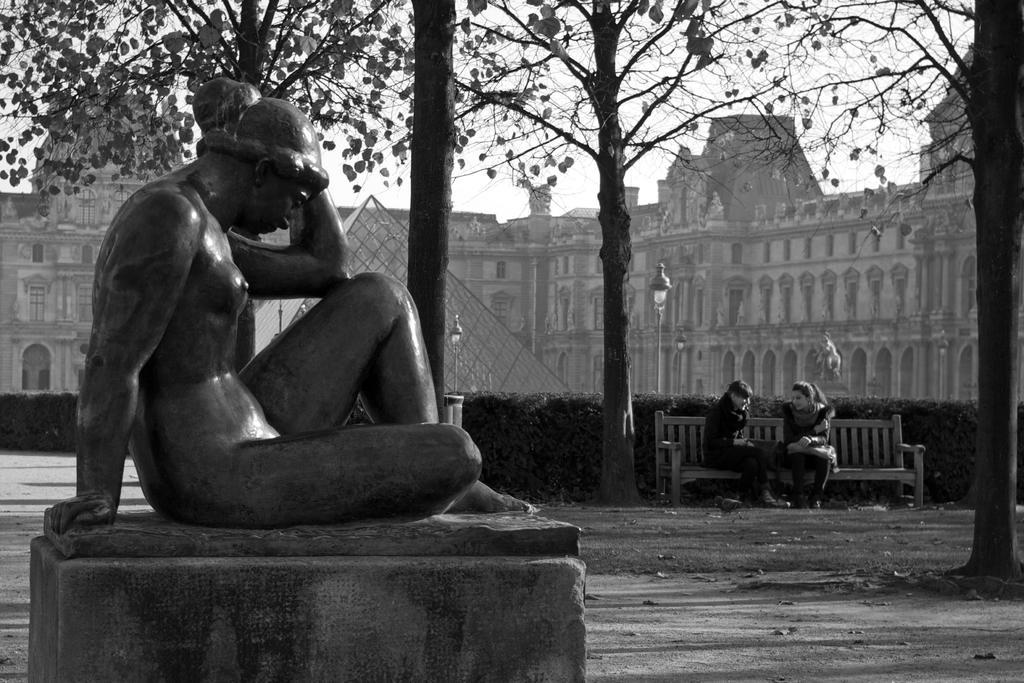Describe this image in one or two sentences. In this image I can see the statue of the person. To the right I can see two people sitting on the bench. I can see many trees and plants to the side of these people. In the background I can see the pole, many buildings and the sky. 